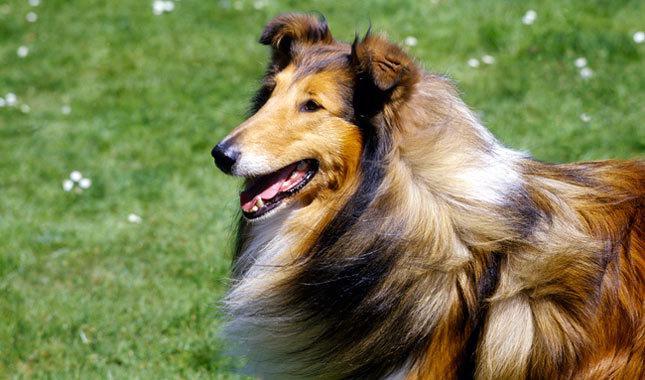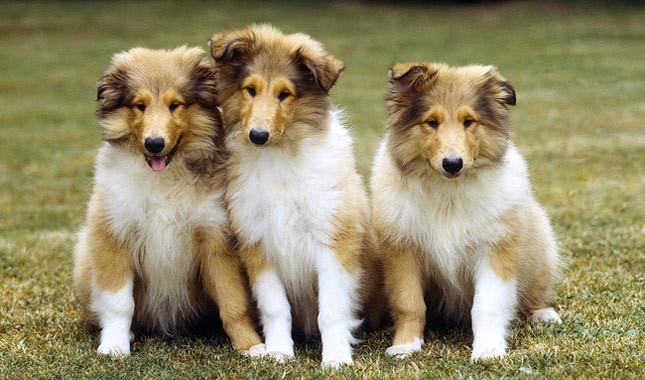The first image is the image on the left, the second image is the image on the right. Evaluate the accuracy of this statement regarding the images: "There are more then one collie on the right image". Is it true? Answer yes or no. Yes. 